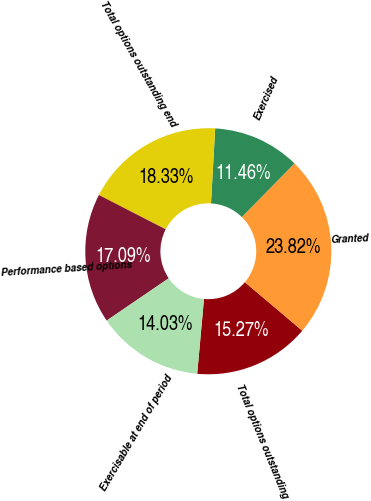Convert chart. <chart><loc_0><loc_0><loc_500><loc_500><pie_chart><fcel>Total options outstanding<fcel>Granted<fcel>Exercised<fcel>Total options outstanding end<fcel>Performance based options<fcel>Exercisable at end of period<nl><fcel>15.27%<fcel>23.82%<fcel>11.46%<fcel>18.33%<fcel>17.09%<fcel>14.03%<nl></chart> 